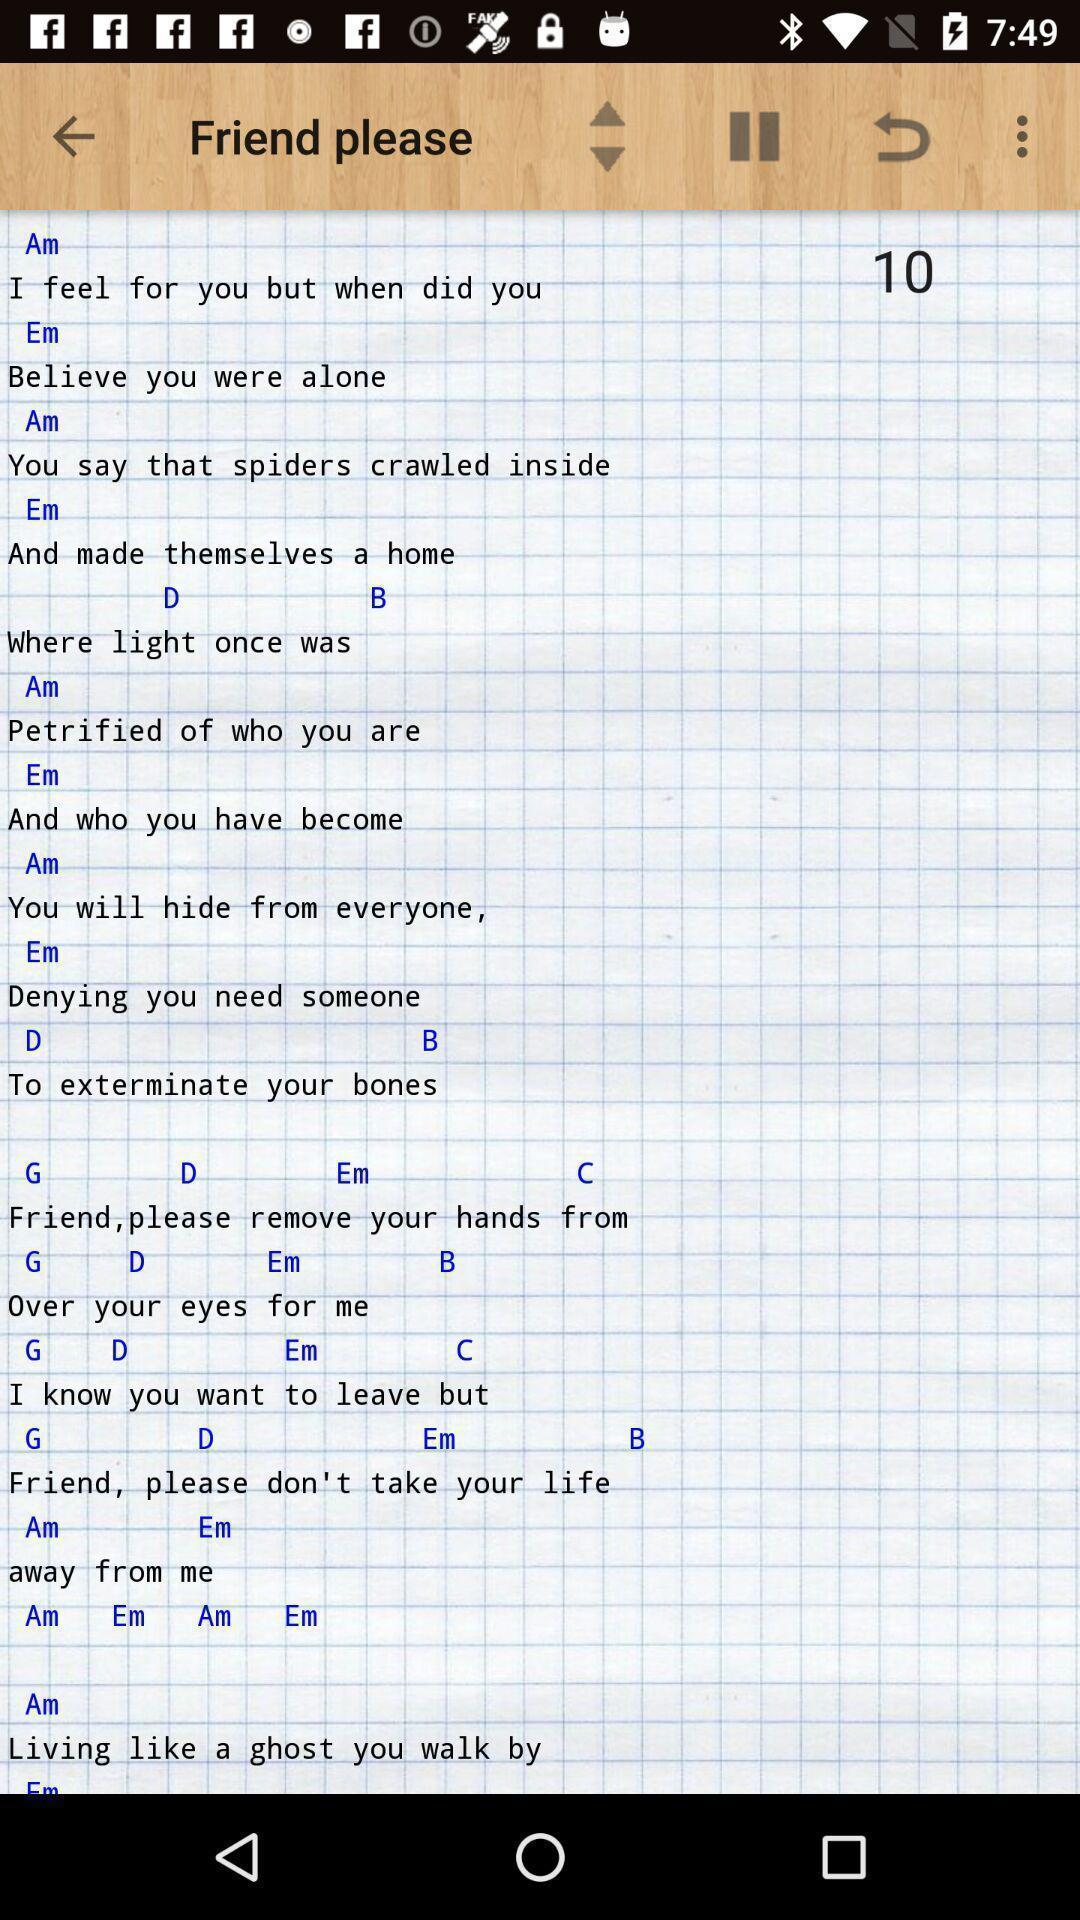Provide a detailed account of this screenshot. Screen shows friend please playing in a music app. 